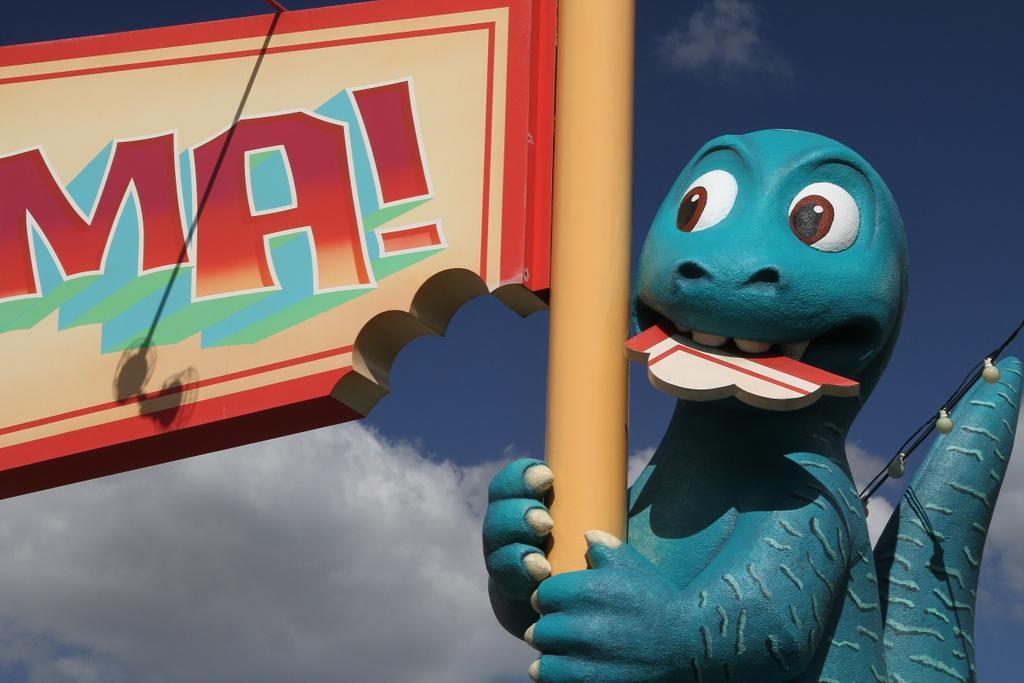Can you describe this image briefly? In this image we can see one blue dinosaur statue with pole, some small lights with wire, one red board with text attached to the pole, one small rod on the top of the red board, one wooden object on the dinosaur statues mouth and there is the sky in the background. 